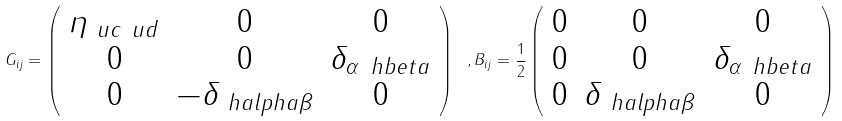Convert formula to latex. <formula><loc_0><loc_0><loc_500><loc_500>G _ { i j } = \left ( \begin{array} { c c c } \eta _ { \ u c \ u d } & 0 & 0 \\ 0 & 0 & \delta _ { \alpha \ h b e t a } \\ 0 & - \delta _ { \ h a l p h a \beta } & 0 \\ \end{array} \right ) \ , B _ { i j } = \frac { 1 } { 2 } \left ( \begin{array} { c c c } 0 & 0 & 0 \\ 0 & 0 & \delta _ { \alpha \ h b e t a } \\ 0 & \delta _ { \ h a l p h a \beta } & 0 \\ \end{array} \right ) \</formula> 